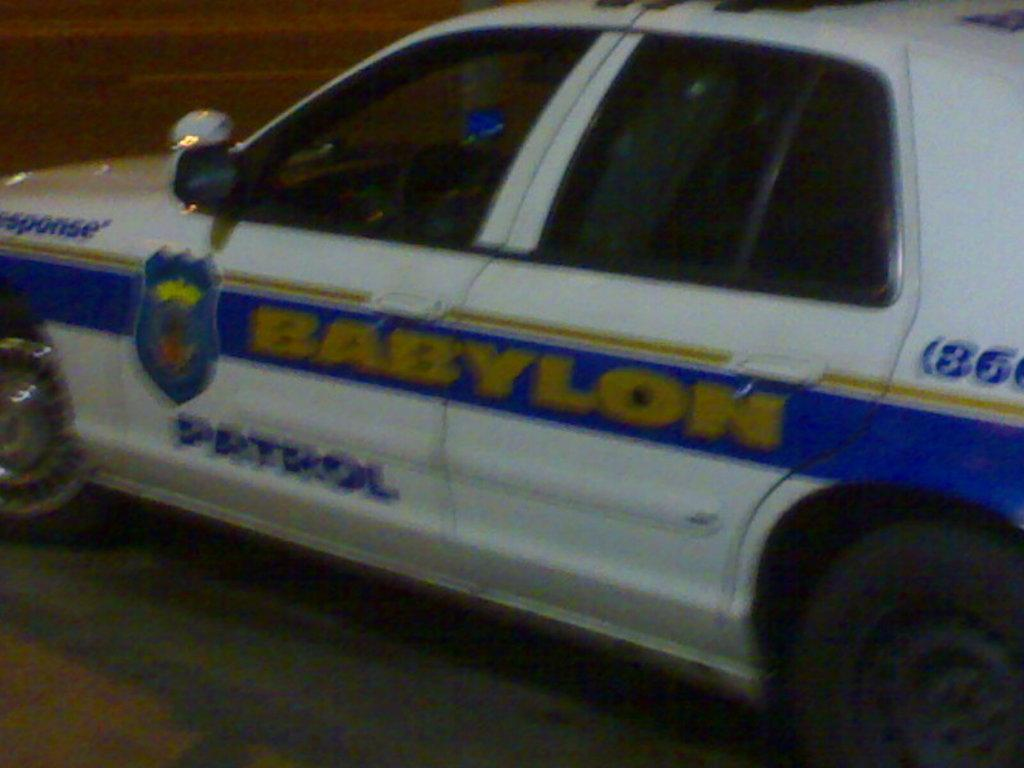Provide a one-sentence caption for the provided image. a car that has the word patrol on the side. 